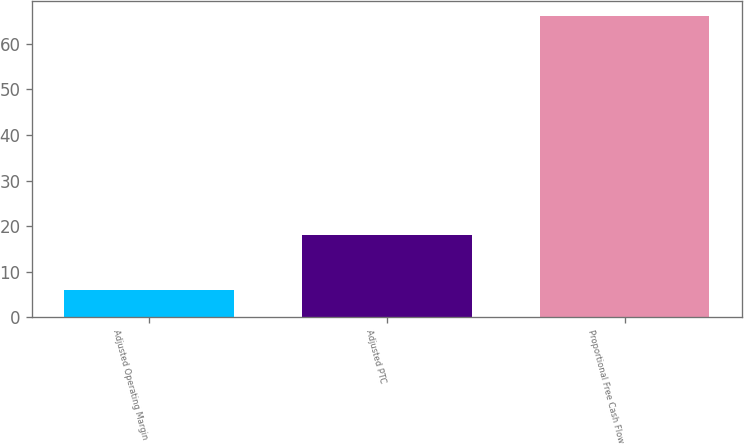Convert chart to OTSL. <chart><loc_0><loc_0><loc_500><loc_500><bar_chart><fcel>Adjusted Operating Margin<fcel>Adjusted PTC<fcel>Proportional Free Cash Flow<nl><fcel>6<fcel>18<fcel>66<nl></chart> 